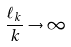<formula> <loc_0><loc_0><loc_500><loc_500>\frac { \ell _ { k } } { k } \to \infty</formula> 